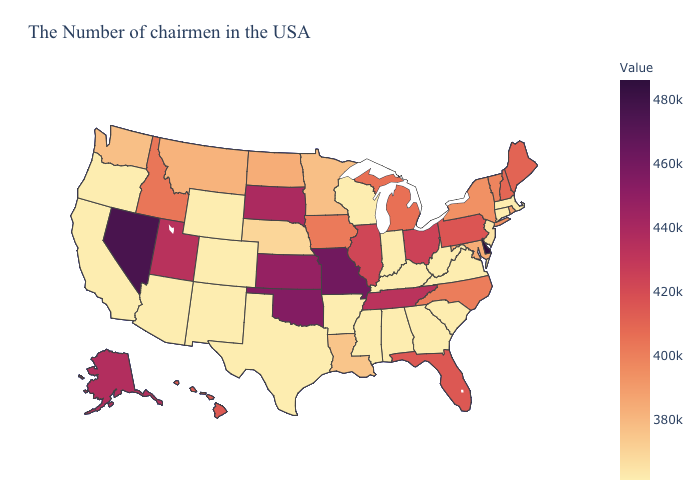Does Delaware have the highest value in the South?
Quick response, please. Yes. Among the states that border Rhode Island , which have the highest value?
Answer briefly. Massachusetts, Connecticut. Among the states that border Indiana , does Ohio have the highest value?
Give a very brief answer. Yes. Is the legend a continuous bar?
Be succinct. Yes. Does Oklahoma have the lowest value in the USA?
Answer briefly. No. Does the map have missing data?
Give a very brief answer. No. Does Tennessee have the lowest value in the USA?
Keep it brief. No. Which states have the lowest value in the USA?
Answer briefly. Massachusetts, Connecticut, Virginia, South Carolina, West Virginia, Georgia, Kentucky, Indiana, Alabama, Wisconsin, Mississippi, Arkansas, Texas, Wyoming, Colorado, New Mexico, Arizona, California, Oregon. 